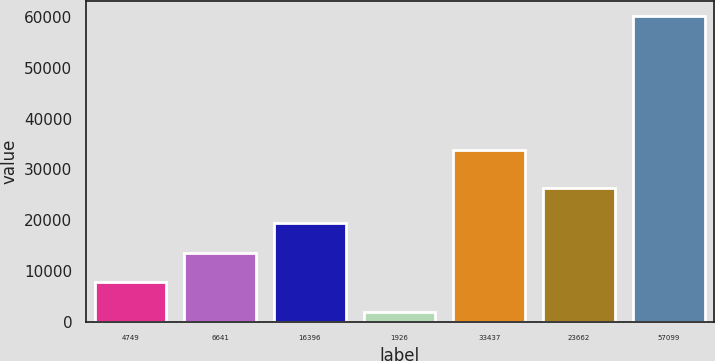<chart> <loc_0><loc_0><loc_500><loc_500><bar_chart><fcel>4749<fcel>6641<fcel>16396<fcel>1926<fcel>33437<fcel>23662<fcel>57099<nl><fcel>7780.6<fcel>13602.2<fcel>19423.8<fcel>1959<fcel>33881<fcel>26294<fcel>60175<nl></chart> 